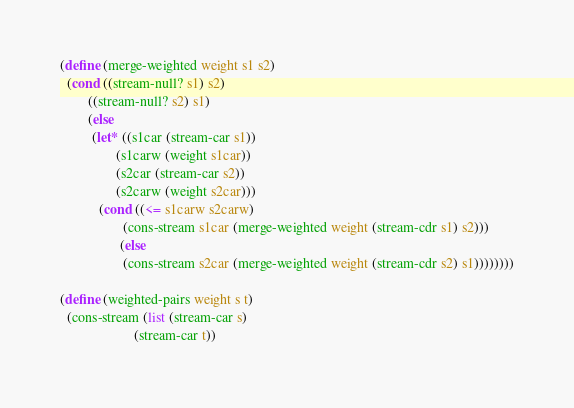Convert code to text. <code><loc_0><loc_0><loc_500><loc_500><_Scheme_>(define (merge-weighted weight s1 s2)
  (cond ((stream-null? s1) s2)
        ((stream-null? s2) s1)
        (else
         (let* ((s1car (stream-car s1))
                (s1carw (weight s1car))
                (s2car (stream-car s2))
                (s2carw (weight s2car)))
           (cond ((<= s1carw s2carw)
                  (cons-stream s1car (merge-weighted weight (stream-cdr s1) s2)))
                 (else
                  (cons-stream s2car (merge-weighted weight (stream-cdr s2) s1))))))))

(define (weighted-pairs weight s t)
  (cons-stream (list (stream-car s)
                     (stream-car t))</code> 